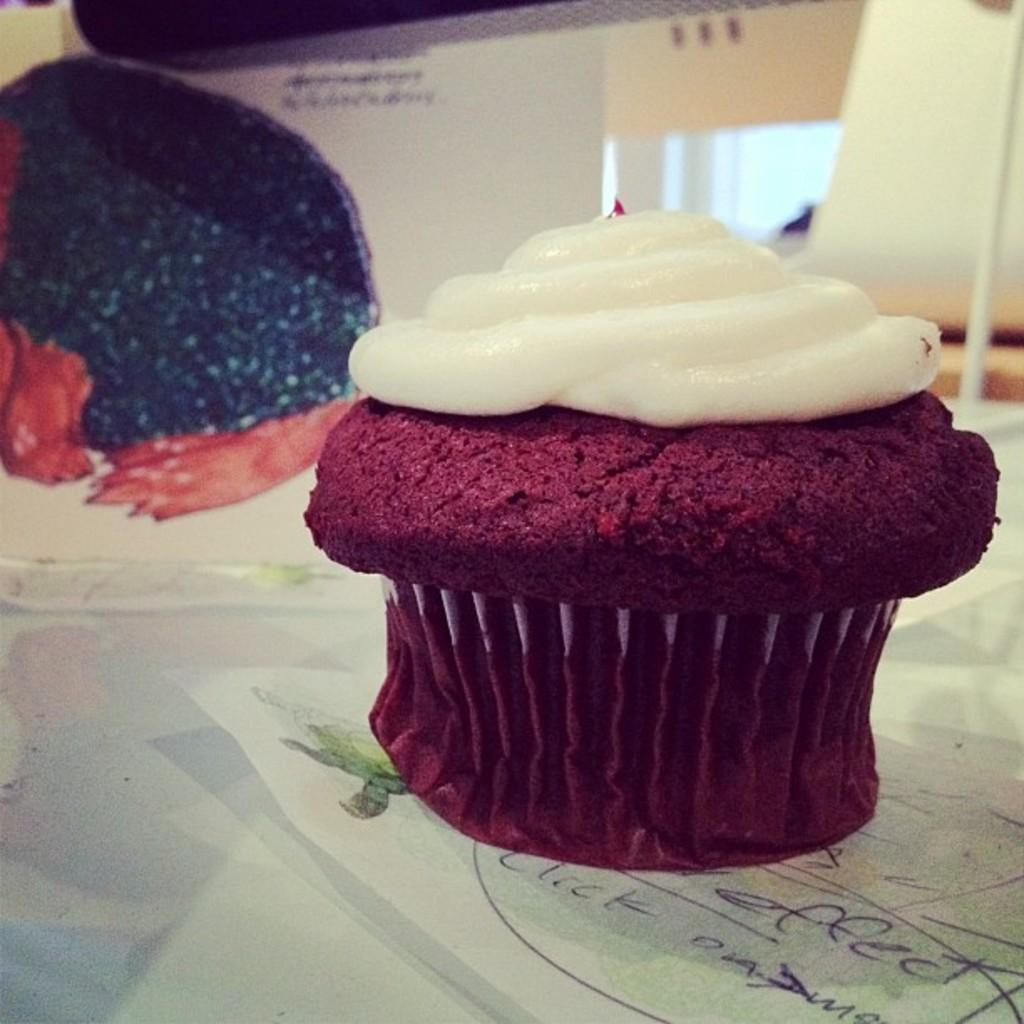What type of food is visible in the image? There is a muffin with cream in the image. What can be seen in the background of the image? There are posters in the background of the image. What piece of furniture is present in the image? There is a table in the image. What type of hen is sitting on the table in the image? There is no hen present in the image; it only features a muffin with cream, posters in the background, and a table. 